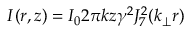<formula> <loc_0><loc_0><loc_500><loc_500>I ( r , z ) = I _ { 0 } 2 \pi k z \gamma ^ { 2 } J _ { 7 } ^ { 2 } ( k _ { \perp } r )</formula> 